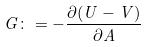Convert formula to latex. <formula><loc_0><loc_0><loc_500><loc_500>G \colon = - \frac { \partial ( U - V ) } { \partial A }</formula> 